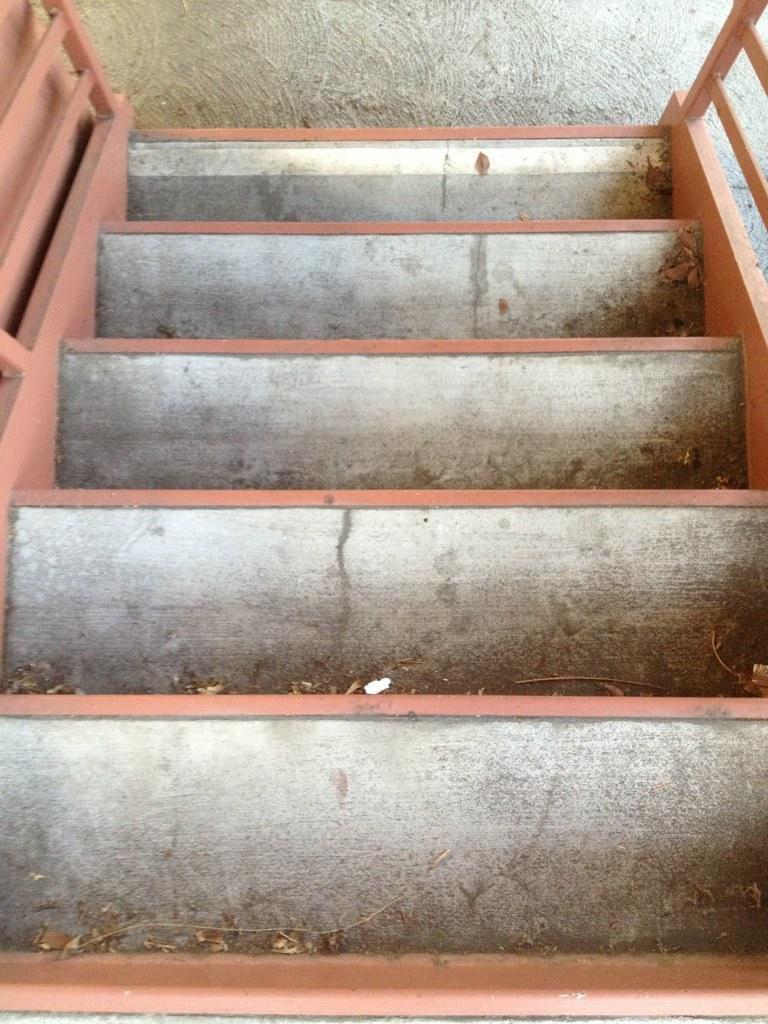Please provide a concise description of this image. In this picture I can see a staircase. 